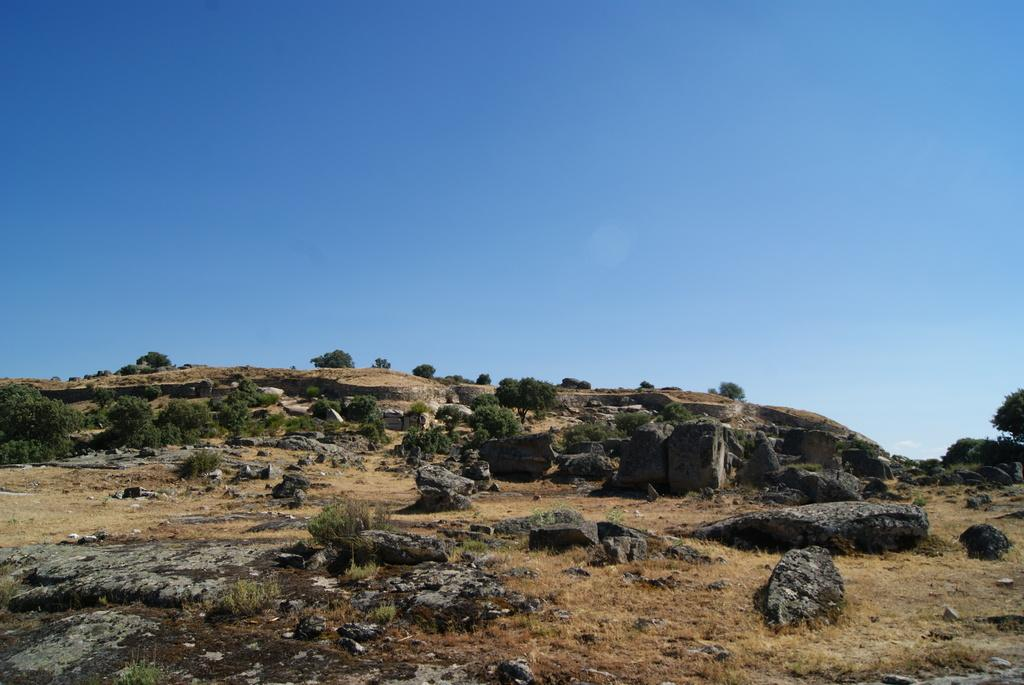What type of terrain is visible in the image? There is ground visible in the image. What natural features can be seen on the ground? There are huge rocks in the image. What is the color of the rocks? The rocks are black in color. What type of vegetation is present in the image? There are trees in the image. What is visible in the background of the image? The sky is visible in the background of the image. Can you tell me how many goats are standing on the rocks in the image? There are no goats present in the image; it features huge black rocks and trees. What color are the eyes of the trees in the image? Trees do not have eyes, so this question cannot be answered. 